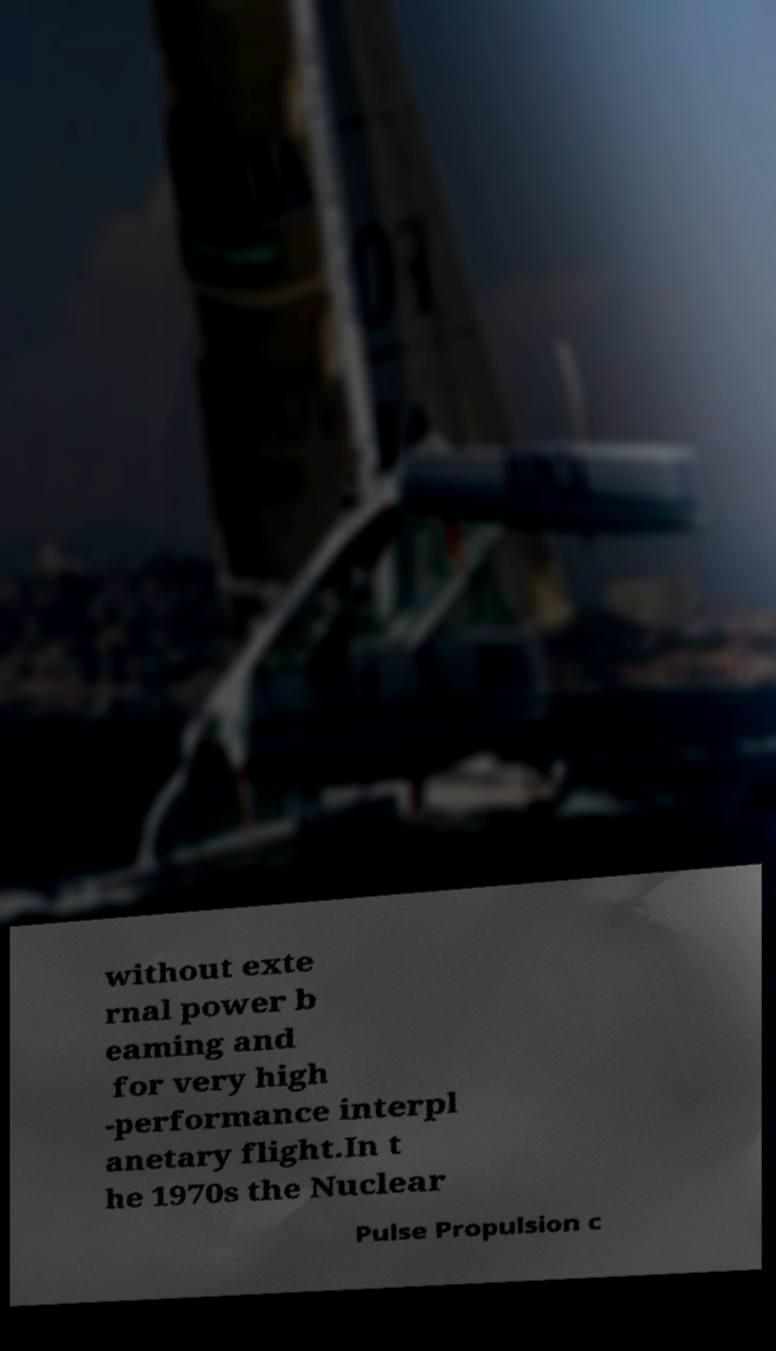There's text embedded in this image that I need extracted. Can you transcribe it verbatim? without exte rnal power b eaming and for very high -performance interpl anetary flight.In t he 1970s the Nuclear Pulse Propulsion c 